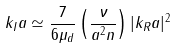<formula> <loc_0><loc_0><loc_500><loc_500>k _ { I } a \simeq \frac { 7 } { 6 \mu _ { d } } \left ( \frac { \nu } { a ^ { 2 } n } \right ) | k _ { R } a | ^ { 2 }</formula> 